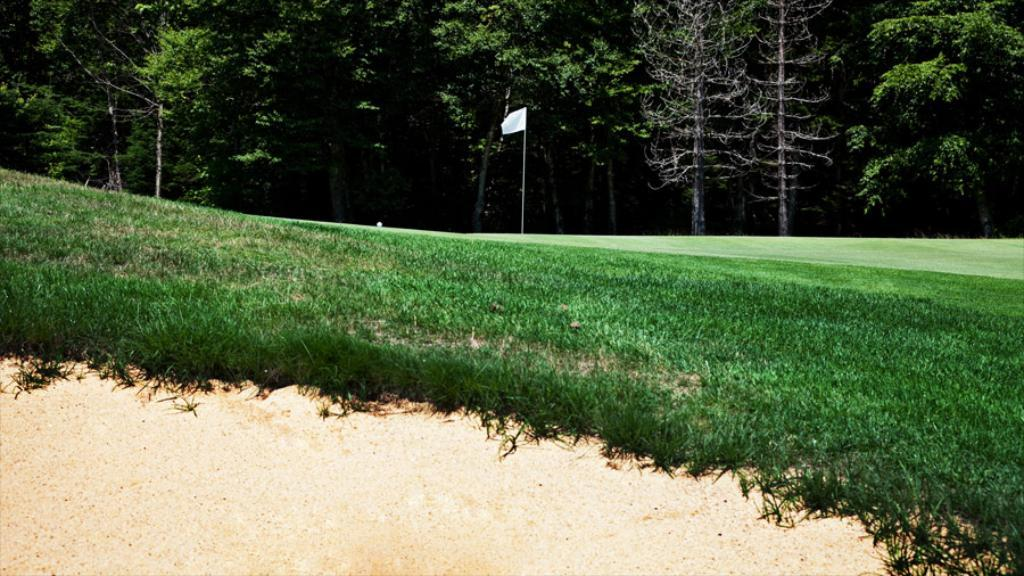What object is on the ground in the image? There is a flag on the ground in the image. What type of terrain is visible at the bottom of the image? Grass and sand are visible at the bottom of the image. What can be seen in the background of the image? There are many toys in the background of the image. Can you hear the flag flapping in the wind in the image? The image is still, so it is not possible to hear any sounds, including the flag flapping in the wind. 